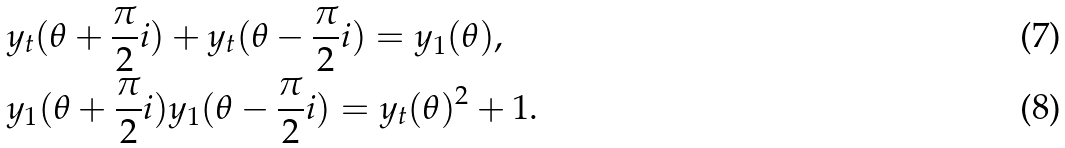<formula> <loc_0><loc_0><loc_500><loc_500>& y _ { t } ( \theta + \frac { \pi } { 2 } i ) + y _ { t } ( \theta - \frac { \pi } { 2 } i ) = y _ { 1 } ( \theta ) , \\ & y _ { 1 } ( \theta + \frac { \pi } { 2 } i ) y _ { 1 } ( \theta - \frac { \pi } { 2 } i ) = y _ { t } ( \theta ) ^ { 2 } + 1 .</formula> 